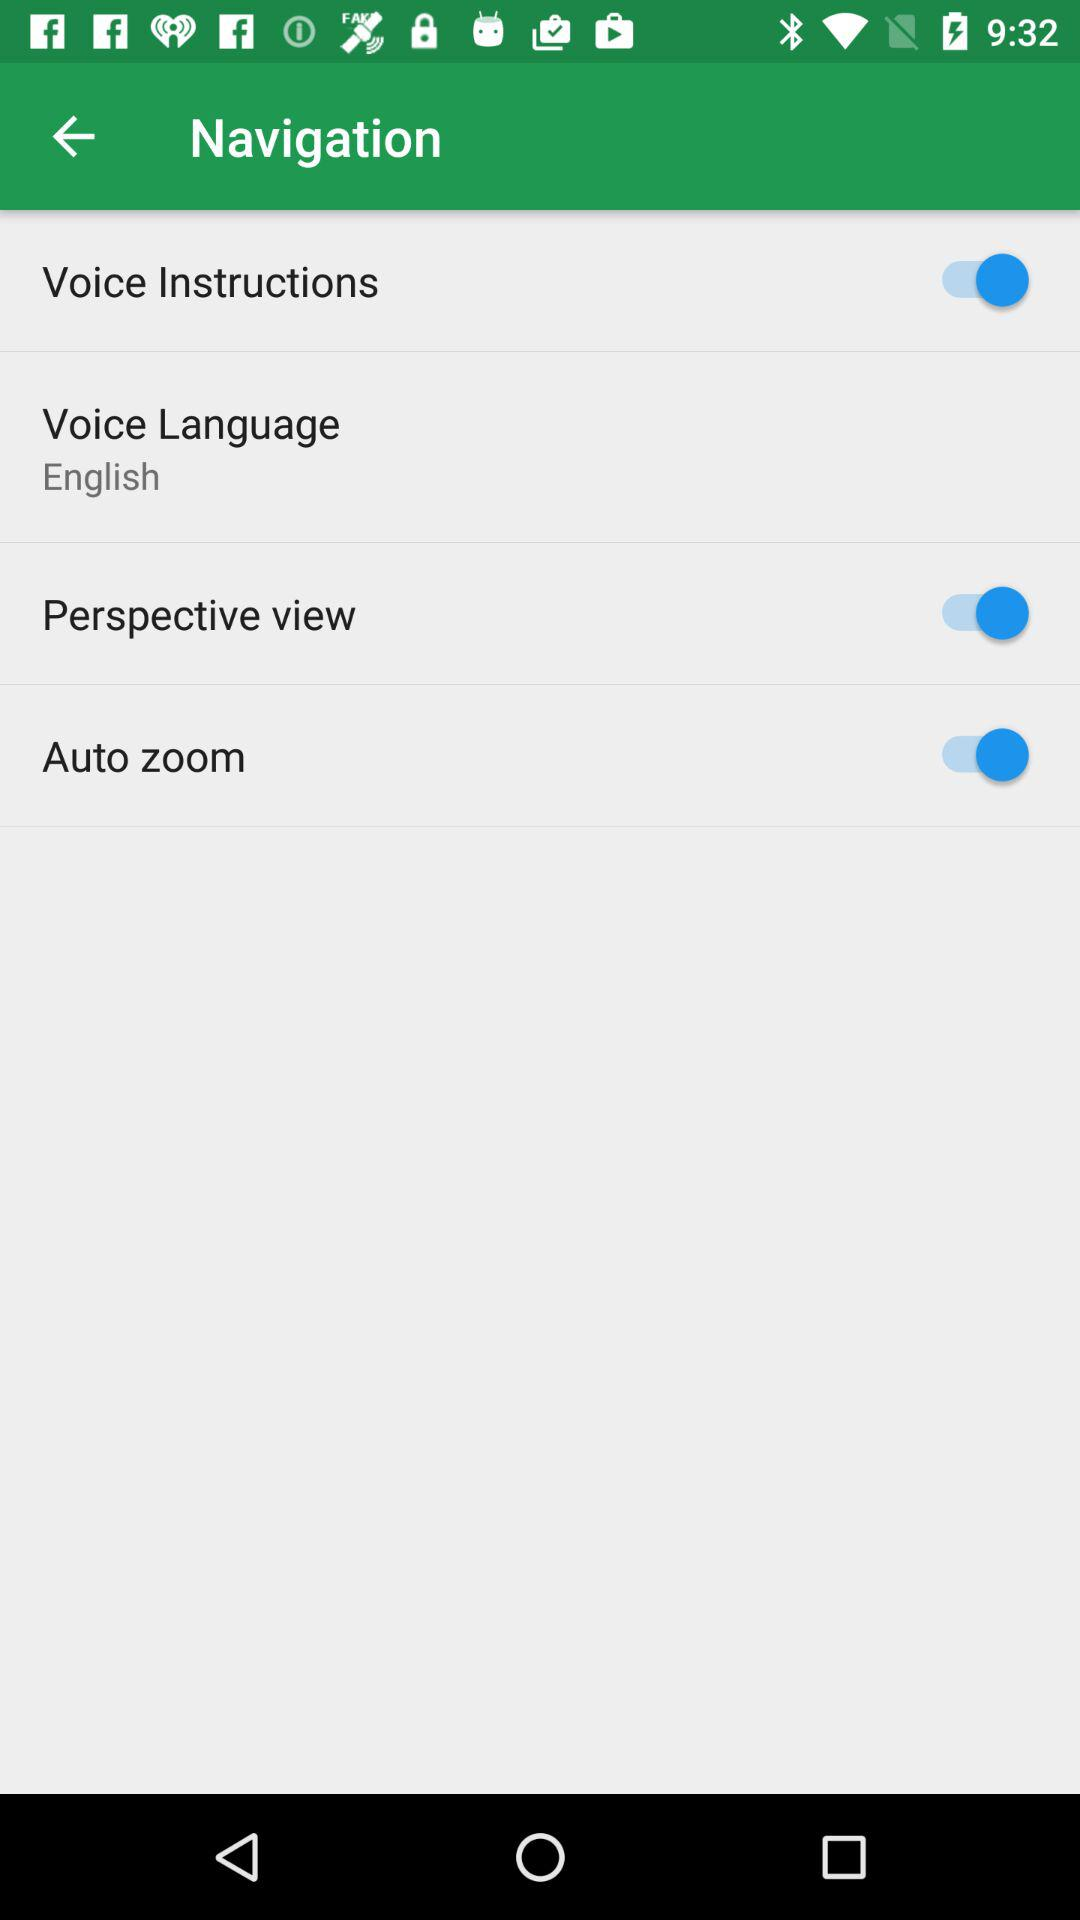What is the status of voice instructions? The status of voice instructions is on. 